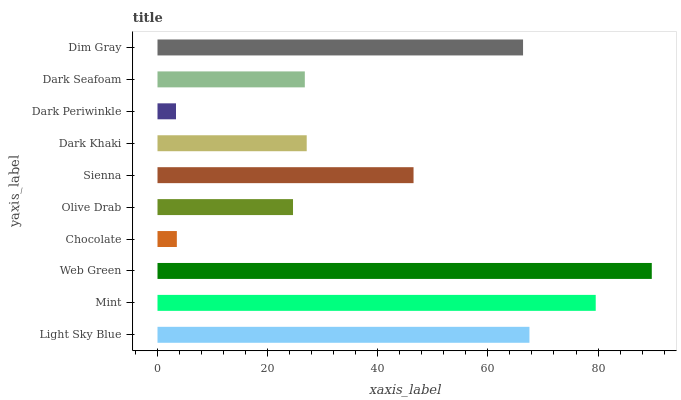Is Dark Periwinkle the minimum?
Answer yes or no. Yes. Is Web Green the maximum?
Answer yes or no. Yes. Is Mint the minimum?
Answer yes or no. No. Is Mint the maximum?
Answer yes or no. No. Is Mint greater than Light Sky Blue?
Answer yes or no. Yes. Is Light Sky Blue less than Mint?
Answer yes or no. Yes. Is Light Sky Blue greater than Mint?
Answer yes or no. No. Is Mint less than Light Sky Blue?
Answer yes or no. No. Is Sienna the high median?
Answer yes or no. Yes. Is Dark Khaki the low median?
Answer yes or no. Yes. Is Dark Periwinkle the high median?
Answer yes or no. No. Is Dark Seafoam the low median?
Answer yes or no. No. 